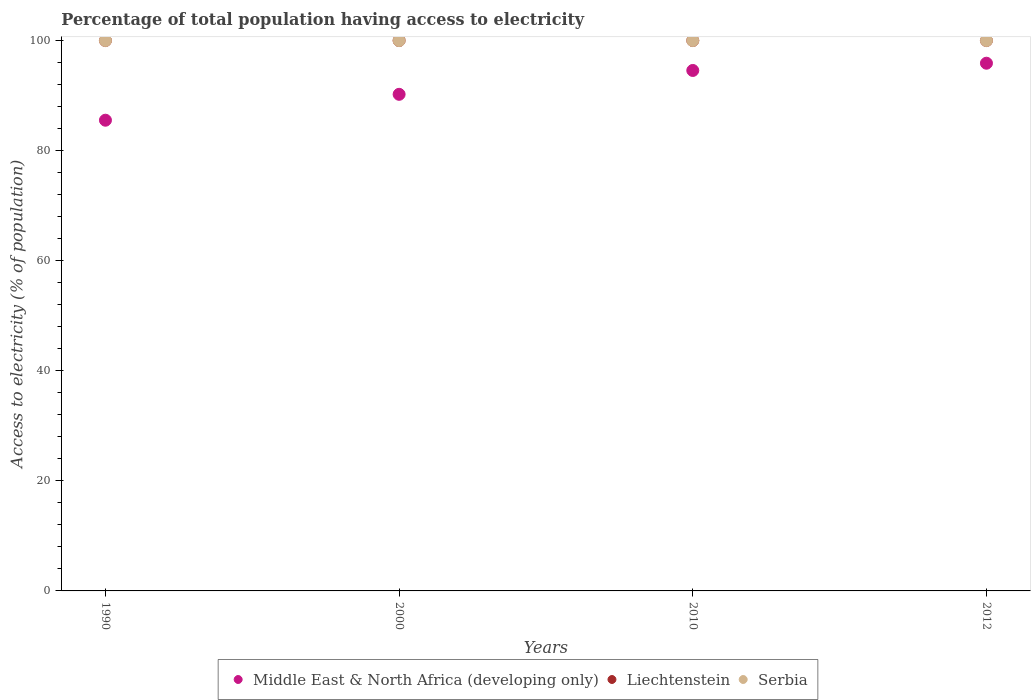How many different coloured dotlines are there?
Your answer should be compact. 3. What is the percentage of population that have access to electricity in Middle East & North Africa (developing only) in 1990?
Make the answer very short. 85.53. Across all years, what is the maximum percentage of population that have access to electricity in Middle East & North Africa (developing only)?
Your answer should be compact. 95.88. Across all years, what is the minimum percentage of population that have access to electricity in Middle East & North Africa (developing only)?
Keep it short and to the point. 85.53. In which year was the percentage of population that have access to electricity in Liechtenstein maximum?
Your response must be concise. 1990. What is the total percentage of population that have access to electricity in Middle East & North Africa (developing only) in the graph?
Ensure brevity in your answer.  366.21. What is the difference between the percentage of population that have access to electricity in Middle East & North Africa (developing only) in 2010 and that in 2012?
Offer a terse response. -1.32. In the year 1990, what is the difference between the percentage of population that have access to electricity in Serbia and percentage of population that have access to electricity in Middle East & North Africa (developing only)?
Keep it short and to the point. 14.47. Is the percentage of population that have access to electricity in Liechtenstein in 1990 less than that in 2012?
Give a very brief answer. No. What is the difference between the highest and the lowest percentage of population that have access to electricity in Liechtenstein?
Provide a short and direct response. 0. Is the sum of the percentage of population that have access to electricity in Middle East & North Africa (developing only) in 1990 and 2010 greater than the maximum percentage of population that have access to electricity in Serbia across all years?
Provide a succinct answer. Yes. Is it the case that in every year, the sum of the percentage of population that have access to electricity in Middle East & North Africa (developing only) and percentage of population that have access to electricity in Serbia  is greater than the percentage of population that have access to electricity in Liechtenstein?
Provide a short and direct response. Yes. Does the percentage of population that have access to electricity in Serbia monotonically increase over the years?
Your response must be concise. No. Is the percentage of population that have access to electricity in Middle East & North Africa (developing only) strictly less than the percentage of population that have access to electricity in Liechtenstein over the years?
Provide a succinct answer. Yes. How many dotlines are there?
Your answer should be compact. 3. What is the difference between two consecutive major ticks on the Y-axis?
Give a very brief answer. 20. Are the values on the major ticks of Y-axis written in scientific E-notation?
Give a very brief answer. No. What is the title of the graph?
Offer a terse response. Percentage of total population having access to electricity. What is the label or title of the Y-axis?
Your answer should be compact. Access to electricity (% of population). What is the Access to electricity (% of population) in Middle East & North Africa (developing only) in 1990?
Provide a succinct answer. 85.53. What is the Access to electricity (% of population) in Liechtenstein in 1990?
Ensure brevity in your answer.  100. What is the Access to electricity (% of population) of Serbia in 1990?
Ensure brevity in your answer.  100. What is the Access to electricity (% of population) in Middle East & North Africa (developing only) in 2000?
Your response must be concise. 90.23. What is the Access to electricity (% of population) in Middle East & North Africa (developing only) in 2010?
Offer a terse response. 94.57. What is the Access to electricity (% of population) in Serbia in 2010?
Give a very brief answer. 100. What is the Access to electricity (% of population) of Middle East & North Africa (developing only) in 2012?
Provide a succinct answer. 95.88. Across all years, what is the maximum Access to electricity (% of population) in Middle East & North Africa (developing only)?
Keep it short and to the point. 95.88. Across all years, what is the maximum Access to electricity (% of population) of Liechtenstein?
Ensure brevity in your answer.  100. Across all years, what is the minimum Access to electricity (% of population) of Middle East & North Africa (developing only)?
Provide a short and direct response. 85.53. Across all years, what is the minimum Access to electricity (% of population) in Liechtenstein?
Provide a succinct answer. 100. What is the total Access to electricity (% of population) in Middle East & North Africa (developing only) in the graph?
Your answer should be very brief. 366.21. What is the total Access to electricity (% of population) in Liechtenstein in the graph?
Your response must be concise. 400. What is the difference between the Access to electricity (% of population) of Middle East & North Africa (developing only) in 1990 and that in 2000?
Your answer should be very brief. -4.7. What is the difference between the Access to electricity (% of population) of Serbia in 1990 and that in 2000?
Make the answer very short. 0. What is the difference between the Access to electricity (% of population) in Middle East & North Africa (developing only) in 1990 and that in 2010?
Provide a succinct answer. -9.04. What is the difference between the Access to electricity (% of population) of Serbia in 1990 and that in 2010?
Provide a short and direct response. 0. What is the difference between the Access to electricity (% of population) of Middle East & North Africa (developing only) in 1990 and that in 2012?
Your response must be concise. -10.36. What is the difference between the Access to electricity (% of population) of Middle East & North Africa (developing only) in 2000 and that in 2010?
Your response must be concise. -4.34. What is the difference between the Access to electricity (% of population) of Liechtenstein in 2000 and that in 2010?
Your answer should be very brief. 0. What is the difference between the Access to electricity (% of population) of Middle East & North Africa (developing only) in 2000 and that in 2012?
Provide a short and direct response. -5.65. What is the difference between the Access to electricity (% of population) of Liechtenstein in 2000 and that in 2012?
Offer a very short reply. 0. What is the difference between the Access to electricity (% of population) of Middle East & North Africa (developing only) in 2010 and that in 2012?
Keep it short and to the point. -1.32. What is the difference between the Access to electricity (% of population) of Liechtenstein in 2010 and that in 2012?
Your answer should be compact. 0. What is the difference between the Access to electricity (% of population) in Middle East & North Africa (developing only) in 1990 and the Access to electricity (% of population) in Liechtenstein in 2000?
Your answer should be compact. -14.47. What is the difference between the Access to electricity (% of population) in Middle East & North Africa (developing only) in 1990 and the Access to electricity (% of population) in Serbia in 2000?
Offer a very short reply. -14.47. What is the difference between the Access to electricity (% of population) in Liechtenstein in 1990 and the Access to electricity (% of population) in Serbia in 2000?
Ensure brevity in your answer.  0. What is the difference between the Access to electricity (% of population) in Middle East & North Africa (developing only) in 1990 and the Access to electricity (% of population) in Liechtenstein in 2010?
Offer a terse response. -14.47. What is the difference between the Access to electricity (% of population) of Middle East & North Africa (developing only) in 1990 and the Access to electricity (% of population) of Serbia in 2010?
Make the answer very short. -14.47. What is the difference between the Access to electricity (% of population) in Liechtenstein in 1990 and the Access to electricity (% of population) in Serbia in 2010?
Keep it short and to the point. 0. What is the difference between the Access to electricity (% of population) in Middle East & North Africa (developing only) in 1990 and the Access to electricity (% of population) in Liechtenstein in 2012?
Provide a succinct answer. -14.47. What is the difference between the Access to electricity (% of population) in Middle East & North Africa (developing only) in 1990 and the Access to electricity (% of population) in Serbia in 2012?
Make the answer very short. -14.47. What is the difference between the Access to electricity (% of population) in Liechtenstein in 1990 and the Access to electricity (% of population) in Serbia in 2012?
Your response must be concise. 0. What is the difference between the Access to electricity (% of population) of Middle East & North Africa (developing only) in 2000 and the Access to electricity (% of population) of Liechtenstein in 2010?
Offer a very short reply. -9.77. What is the difference between the Access to electricity (% of population) of Middle East & North Africa (developing only) in 2000 and the Access to electricity (% of population) of Serbia in 2010?
Your response must be concise. -9.77. What is the difference between the Access to electricity (% of population) in Liechtenstein in 2000 and the Access to electricity (% of population) in Serbia in 2010?
Offer a very short reply. 0. What is the difference between the Access to electricity (% of population) of Middle East & North Africa (developing only) in 2000 and the Access to electricity (% of population) of Liechtenstein in 2012?
Your response must be concise. -9.77. What is the difference between the Access to electricity (% of population) of Middle East & North Africa (developing only) in 2000 and the Access to electricity (% of population) of Serbia in 2012?
Make the answer very short. -9.77. What is the difference between the Access to electricity (% of population) of Liechtenstein in 2000 and the Access to electricity (% of population) of Serbia in 2012?
Offer a terse response. 0. What is the difference between the Access to electricity (% of population) of Middle East & North Africa (developing only) in 2010 and the Access to electricity (% of population) of Liechtenstein in 2012?
Your answer should be very brief. -5.43. What is the difference between the Access to electricity (% of population) of Middle East & North Africa (developing only) in 2010 and the Access to electricity (% of population) of Serbia in 2012?
Your answer should be very brief. -5.43. What is the difference between the Access to electricity (% of population) in Liechtenstein in 2010 and the Access to electricity (% of population) in Serbia in 2012?
Your answer should be compact. 0. What is the average Access to electricity (% of population) of Middle East & North Africa (developing only) per year?
Provide a succinct answer. 91.55. What is the average Access to electricity (% of population) of Liechtenstein per year?
Offer a terse response. 100. What is the average Access to electricity (% of population) in Serbia per year?
Give a very brief answer. 100. In the year 1990, what is the difference between the Access to electricity (% of population) in Middle East & North Africa (developing only) and Access to electricity (% of population) in Liechtenstein?
Your response must be concise. -14.47. In the year 1990, what is the difference between the Access to electricity (% of population) in Middle East & North Africa (developing only) and Access to electricity (% of population) in Serbia?
Give a very brief answer. -14.47. In the year 2000, what is the difference between the Access to electricity (% of population) in Middle East & North Africa (developing only) and Access to electricity (% of population) in Liechtenstein?
Keep it short and to the point. -9.77. In the year 2000, what is the difference between the Access to electricity (% of population) of Middle East & North Africa (developing only) and Access to electricity (% of population) of Serbia?
Provide a short and direct response. -9.77. In the year 2000, what is the difference between the Access to electricity (% of population) of Liechtenstein and Access to electricity (% of population) of Serbia?
Give a very brief answer. 0. In the year 2010, what is the difference between the Access to electricity (% of population) of Middle East & North Africa (developing only) and Access to electricity (% of population) of Liechtenstein?
Provide a short and direct response. -5.43. In the year 2010, what is the difference between the Access to electricity (% of population) in Middle East & North Africa (developing only) and Access to electricity (% of population) in Serbia?
Provide a short and direct response. -5.43. In the year 2010, what is the difference between the Access to electricity (% of population) of Liechtenstein and Access to electricity (% of population) of Serbia?
Offer a very short reply. 0. In the year 2012, what is the difference between the Access to electricity (% of population) of Middle East & North Africa (developing only) and Access to electricity (% of population) of Liechtenstein?
Ensure brevity in your answer.  -4.12. In the year 2012, what is the difference between the Access to electricity (% of population) of Middle East & North Africa (developing only) and Access to electricity (% of population) of Serbia?
Make the answer very short. -4.12. In the year 2012, what is the difference between the Access to electricity (% of population) of Liechtenstein and Access to electricity (% of population) of Serbia?
Ensure brevity in your answer.  0. What is the ratio of the Access to electricity (% of population) of Middle East & North Africa (developing only) in 1990 to that in 2000?
Give a very brief answer. 0.95. What is the ratio of the Access to electricity (% of population) in Liechtenstein in 1990 to that in 2000?
Your answer should be very brief. 1. What is the ratio of the Access to electricity (% of population) of Middle East & North Africa (developing only) in 1990 to that in 2010?
Your response must be concise. 0.9. What is the ratio of the Access to electricity (% of population) in Middle East & North Africa (developing only) in 1990 to that in 2012?
Your response must be concise. 0.89. What is the ratio of the Access to electricity (% of population) in Middle East & North Africa (developing only) in 2000 to that in 2010?
Provide a succinct answer. 0.95. What is the ratio of the Access to electricity (% of population) of Serbia in 2000 to that in 2010?
Your answer should be compact. 1. What is the ratio of the Access to electricity (% of population) of Middle East & North Africa (developing only) in 2000 to that in 2012?
Offer a terse response. 0.94. What is the ratio of the Access to electricity (% of population) of Middle East & North Africa (developing only) in 2010 to that in 2012?
Your response must be concise. 0.99. What is the ratio of the Access to electricity (% of population) of Liechtenstein in 2010 to that in 2012?
Make the answer very short. 1. What is the difference between the highest and the second highest Access to electricity (% of population) in Middle East & North Africa (developing only)?
Offer a terse response. 1.32. What is the difference between the highest and the lowest Access to electricity (% of population) of Middle East & North Africa (developing only)?
Offer a very short reply. 10.36. 